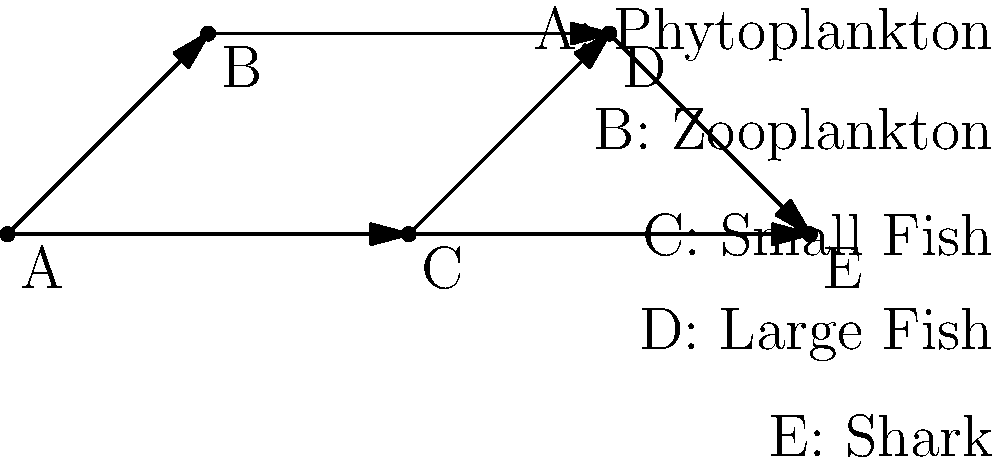Analyze the given food web diagram representing a marine ecosystem. Identify the primary producers and the apex predator in this food web. Additionally, explain how the removal of component C (Small Fish) would impact the ecosystem. To analyze this food web diagram, let's follow these steps:

1. Identify the primary producers:
   - Primary producers are organisms that can produce their own food through photosynthesis.
   - In this diagram, component A (Phytoplankton) is at the base of the food web and has no arrows pointing to it.
   - Therefore, Phytoplankton (A) is the primary producer in this ecosystem.

2. Identify the apex predator:
   - The apex predator is the organism at the top of the food chain with no natural predators.
   - In this diagram, component E (Shark) has only arrows pointing towards it and no arrows leading away from it.
   - Thus, the Shark (E) is the apex predator in this ecosystem.

3. Analyze the impact of removing component C (Small Fish):
   - Small Fish (C) serves as a food source for both Large Fish (D) and Sharks (E).
   - Small Fish also feeds on Phytoplankton (A).
   - If Small Fish were removed:
     a) Large Fish and Sharks would lose a significant food source, potentially causing their populations to decline.
     b) Phytoplankton might experience a population increase due to reduced predation.
     c) Zooplankton (B) might face increased predation pressure from Large Fish as they seek alternative food sources.
     d) The overall biodiversity and stability of the ecosystem would likely be disrupted, as Small Fish play a crucial role in energy transfer between lower and higher trophic levels.

This analysis demonstrates the interconnectedness of species in an ecosystem and the potential cascading effects of removing a single component from the food web.
Answer: Primary producer: Phytoplankton (A). Apex predator: Shark (E). Removing Small Fish (C) would disrupt energy transfer, affecting populations of both predators and prey, potentially destabilizing the ecosystem. 